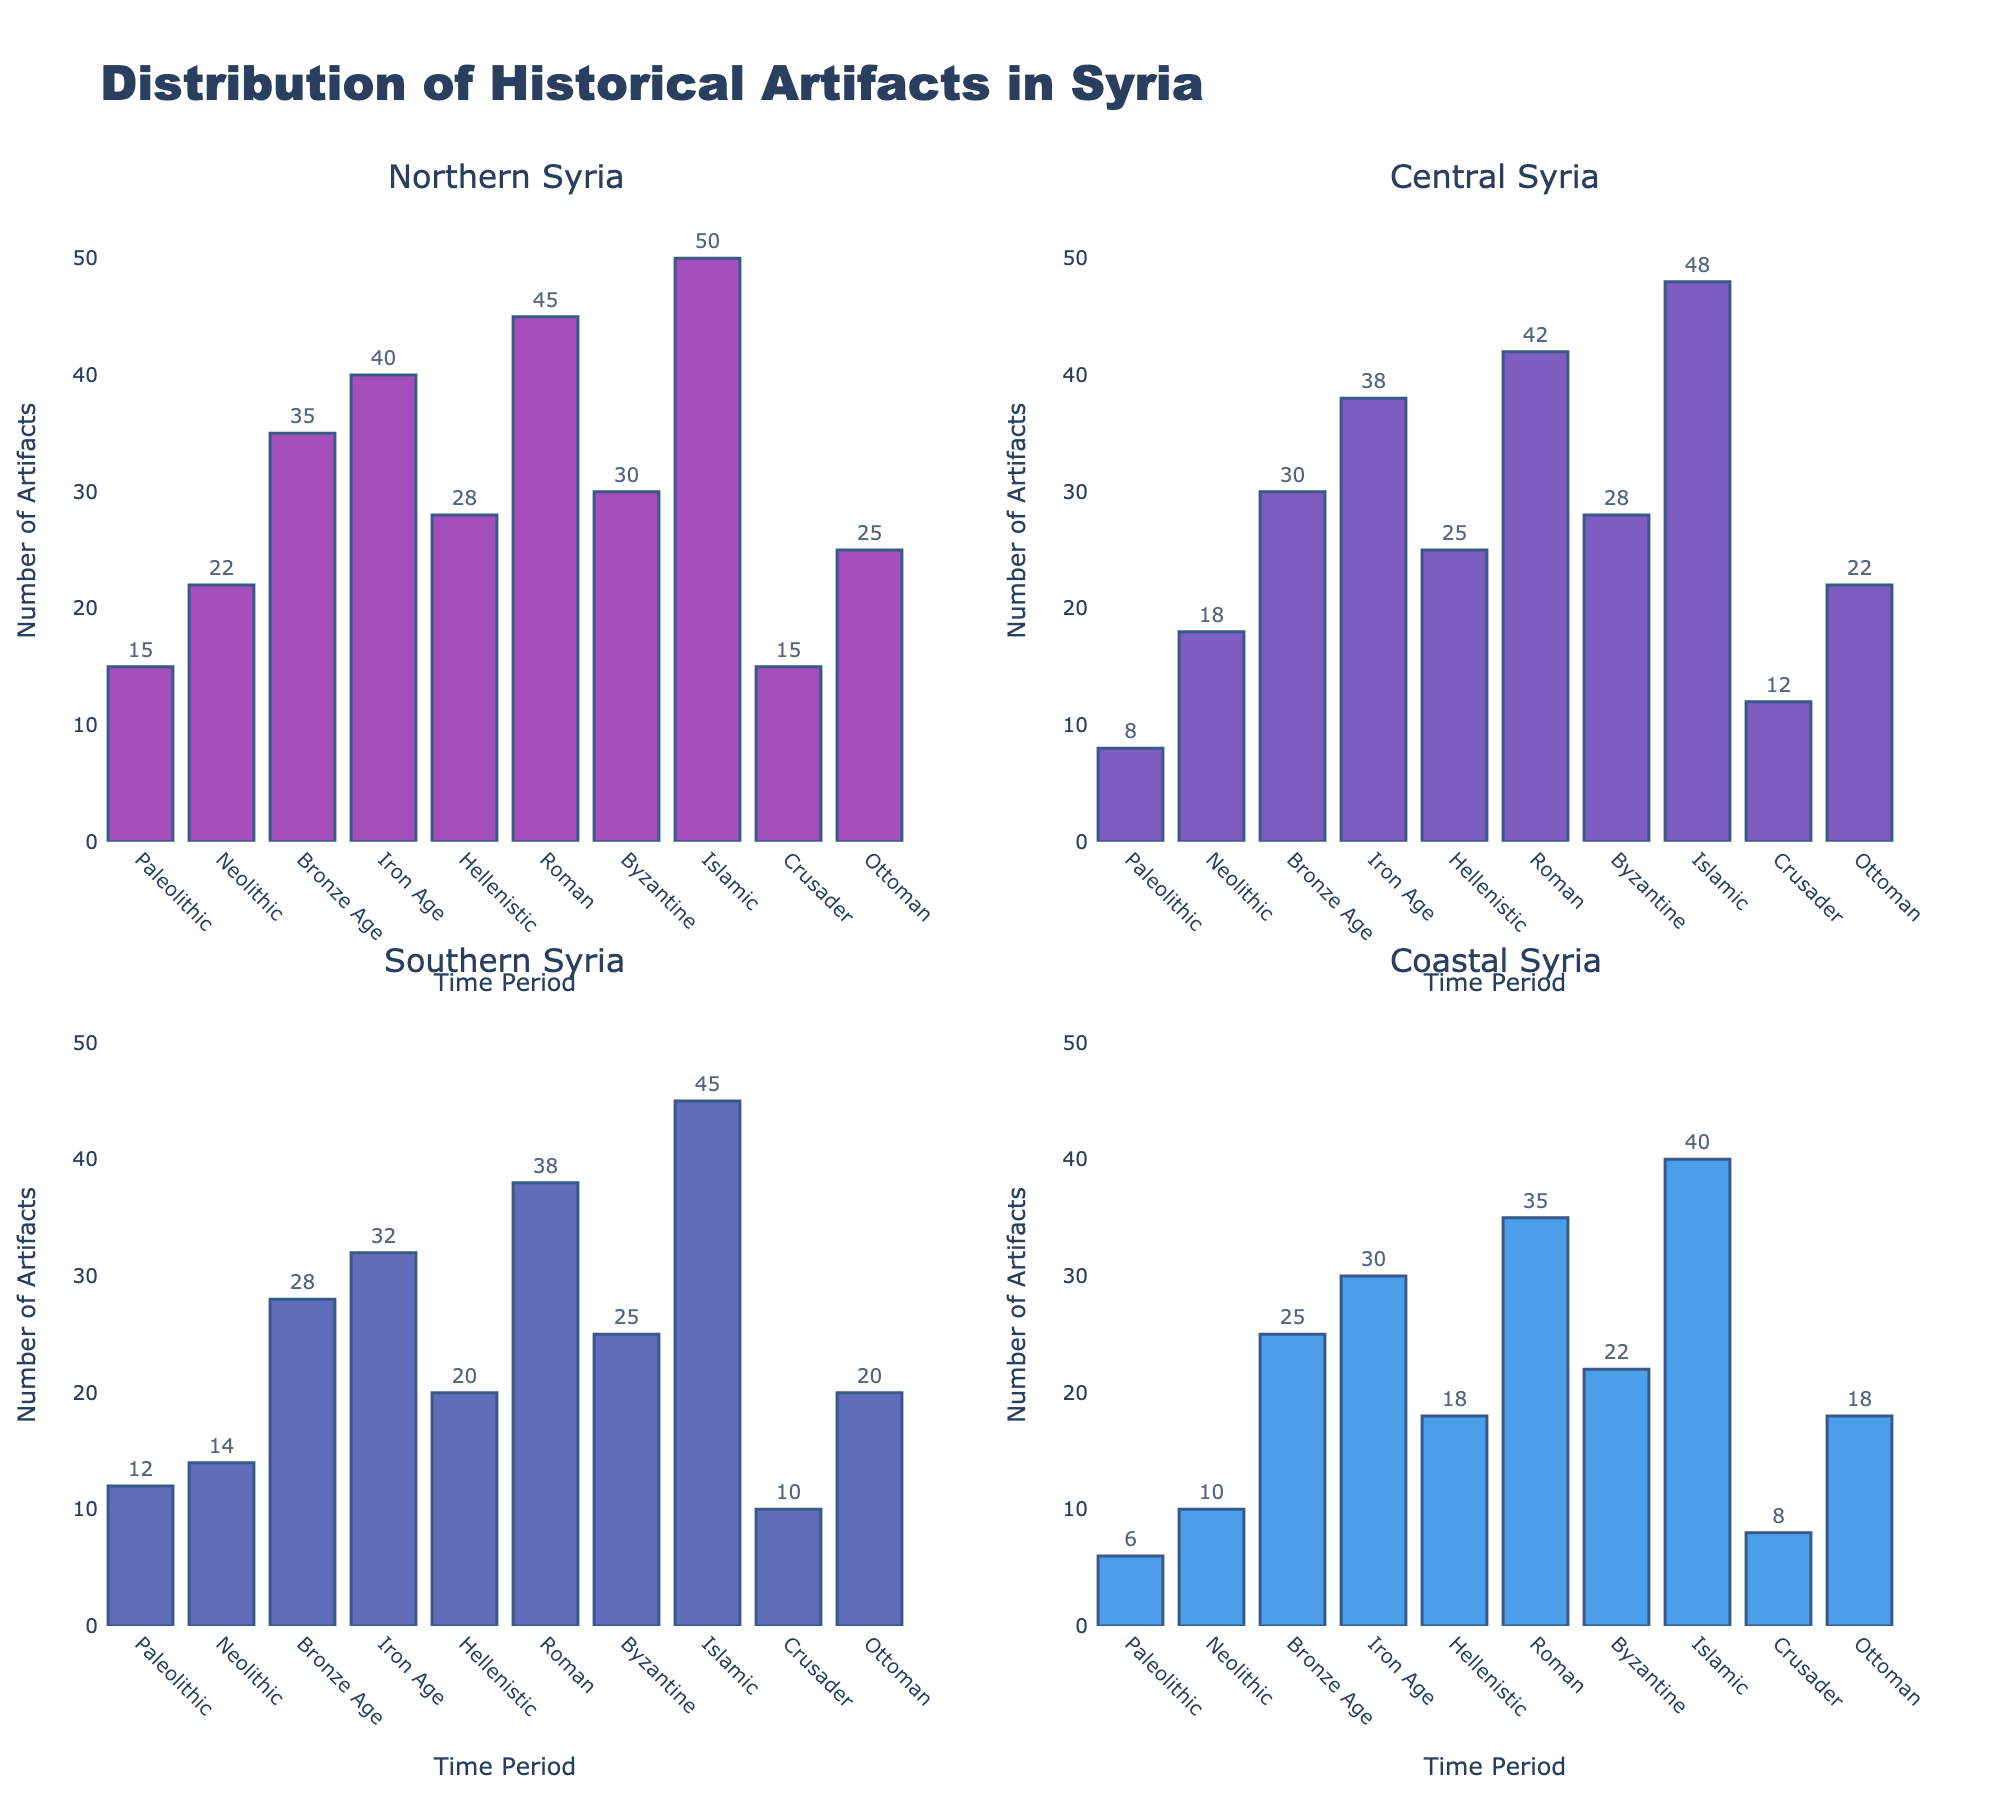What is the percentage of Depression among asylum seekers aged 18-30? The subplot showing the percentage of Depression indicates that the bar for the age group 18-30 reaches 60%.
Answer: 60% Which age group has the highest percentage of Anxiety? Comparing the heights of the Anxiety bars across all age groups, the bar for the age group 18-30 is the highest at 65%.
Answer: 18-30 What is the difference in percentage of PTSD between the Under 18 and Over 60 age groups? The values for PTSD are 35% for Under 18 and 40% for Over 60. The difference is 40% - 35% = 5%.
Answer: 5% How does the percentage of Self-harm vary between the 18-30 and 46-60 age groups? The percentages for Self-harm are 30% for the 18-30 age group and 15% for the 46-60 age group. The difference is 30% - 15% = 15%.
Answer: 15% Which age group shows the lowest percentage for Sleep Disorders? The bar for Sleep Disorders among the Over 60 age group is the lowest, indicating a percentage of 50%.
Answer: Over 60 What is the average percentage of Depression across all age groups? The percentages for Depression are 45%, 60%, 55%, 50%, and 40%. The average is (45 + 60 + 55 + 50 + 40) / 5 = 50%.
Answer: 50% Compare the percentage of Anxiety and Depression in the 31-45 age group. Which is higher? For the 31-45 age group, the Anxiety percentage is 60%, and the Depression percentage is 55%. Anxiety is higher.
Answer: Anxiety For which mental health condition is the variation in percentage across age groups the smallest? Observing the bars, the variation for Self-harm is the smallest, ranging from 10% to 30%, a maximum difference of 20 percentage points.
Answer: Self-harm What is the combined percentage for PTSD and Sleep Disorders in the 31-45 age group? PTSD is 50%, and Sleep Disorders is 65% for the 31-45 age group. The combined percentage is 50% + 65% = 115%.
Answer: 115% 